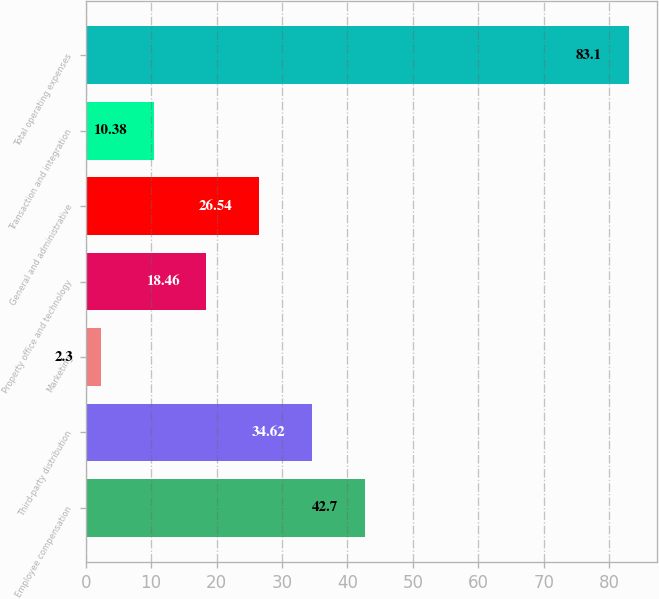Convert chart. <chart><loc_0><loc_0><loc_500><loc_500><bar_chart><fcel>Employee compensation<fcel>Third-party distribution<fcel>Marketing<fcel>Property office and technology<fcel>General and administrative<fcel>Transaction and integration<fcel>Total operating expenses<nl><fcel>42.7<fcel>34.62<fcel>2.3<fcel>18.46<fcel>26.54<fcel>10.38<fcel>83.1<nl></chart> 